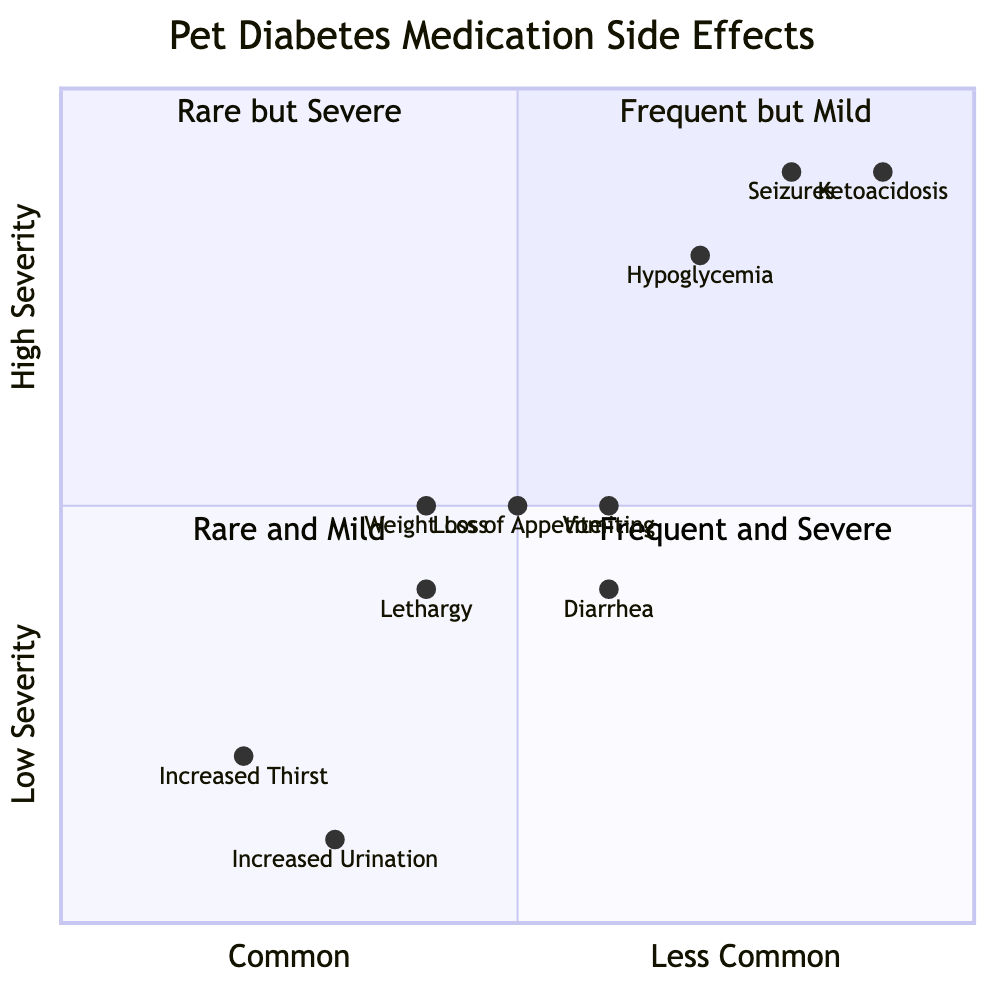What common side effect has low severity? By examining the quadrant chart, we can identify the elements listed under the "Common Side Effects" category and check their severity. "Increased Thirst" and "Increased Urination" are both marked as "Low" severity.
Answer: Increased Thirst, Increased Urination How many side effects fall into the "Rare but Severe" category? The quadrant chart has four segments, and by looking specifically at quadrant 2 ("Rare but Severe"), we can see the side effects listed there, which are "Hypoglycemia," "Seizures," and "Ketoacidosis." Counting these gives us the total.
Answer: 3 Which side effect is the least common and has a high severity? The chart indicates that high severity side effects that are rare are represented in quadrant 2. The side effects listed there are "Hypoglycemia," "Seizures," and "Ketoacidosis." Among these, "Ketoacidosis" is the most extreme case, making it the least common with high severity.
Answer: Ketoacidosis What is the severity of Weight Loss? By locating "Weight Loss" on the quadrant chart, we see it's positioned in the middle, categorized as "Common Side Effects" and marked with a "Medium" severity rating.
Answer: Medium Is there any common side effect that is also rated as high severity? Looking within the "Common Side Effects" quadrant, all listed side effects (“Increased Thirst,” “Increased Urination,” “Weight Loss,” “Lethargy,” “Loss of Appetite”) bear low or medium severity. Hence, no common side effect appears in the high severity designation.
Answer: No 